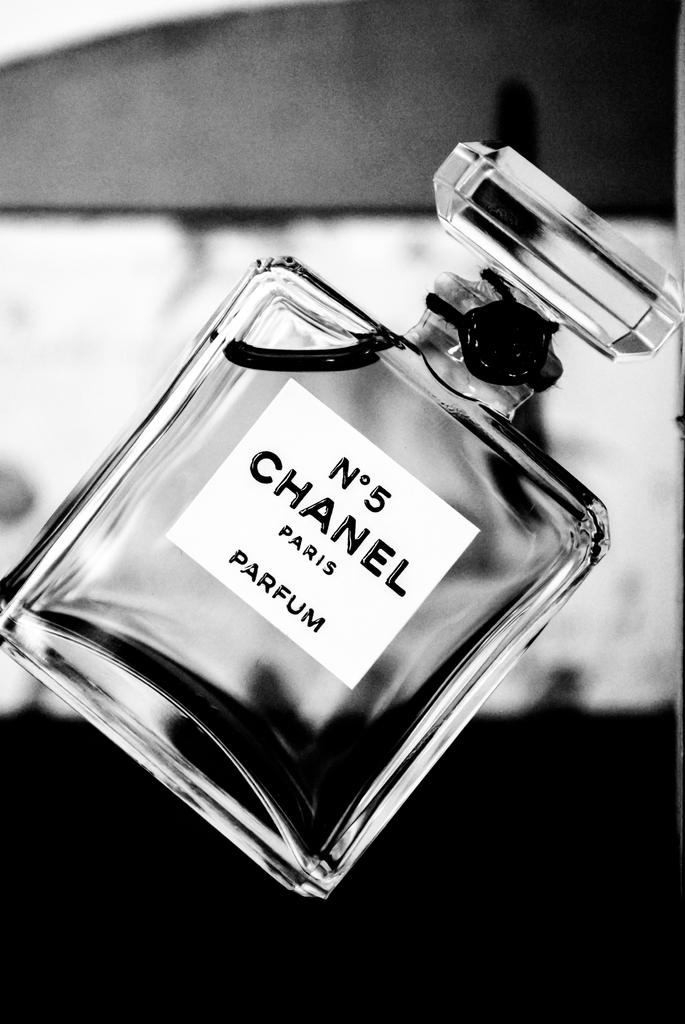Provide a one-sentence caption for the provided image. A glass parfum bottle with the label No 5 Chanel Paris on it. 